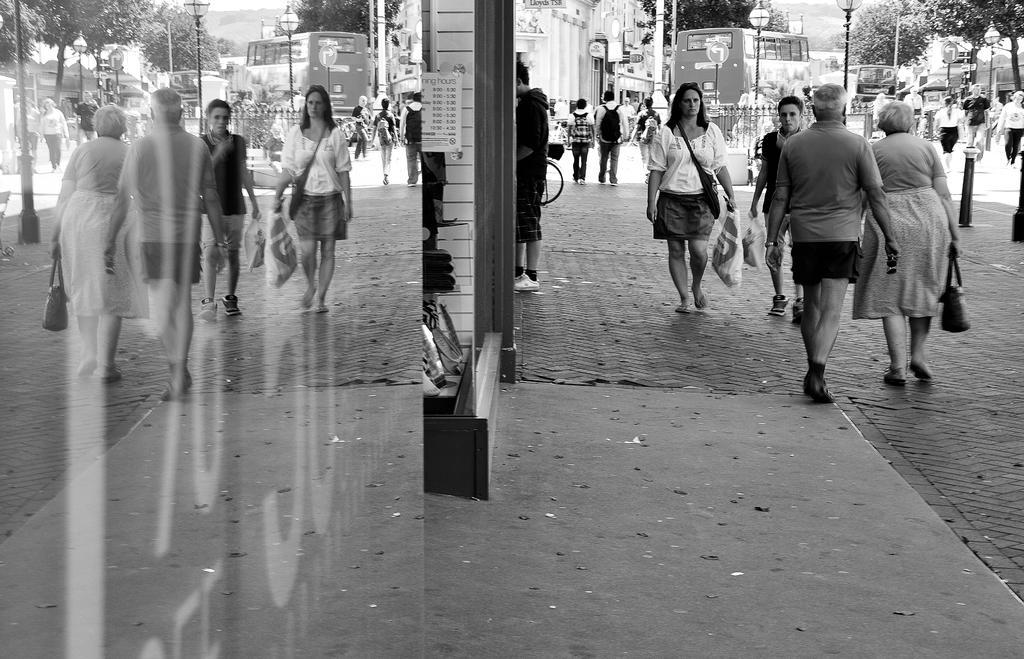In one or two sentences, can you explain what this image depicts? The image is taken on the streets. In the foreground of the picture, where we can see a lot of people walking on the roads. On the left it is a glass window and then there is a building. In the center of the picture there are street light, vehicle and people crossing the road. In the background there are trees, building and sky. 